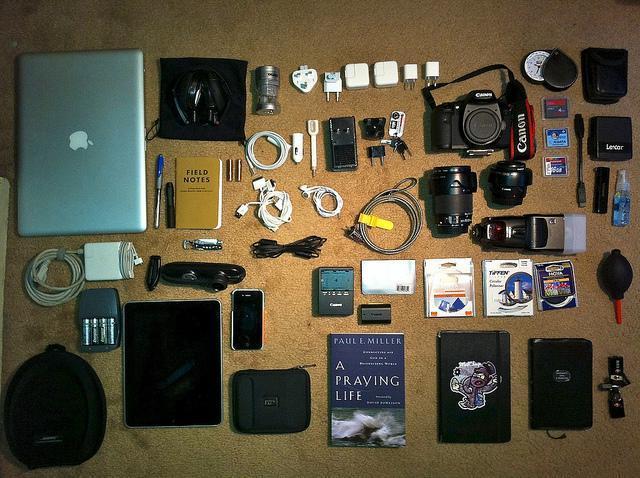How many books are there?
Give a very brief answer. 3. 